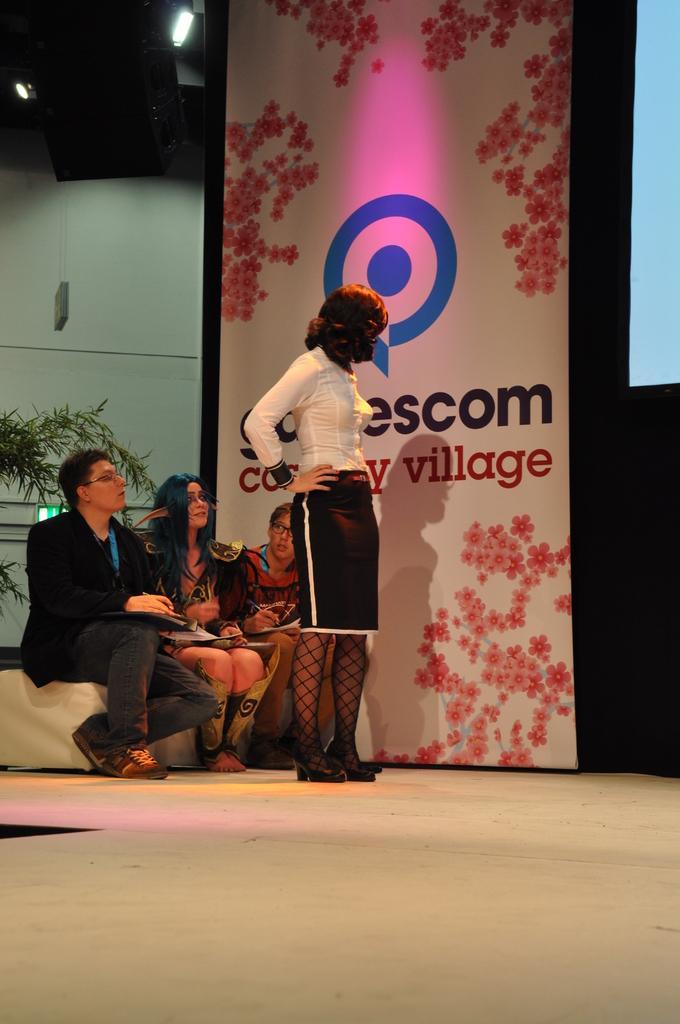How would you summarize this image in a sentence or two? In the center of the image there is a woman standing on the dais. On the left side of the image there are persons sitting. In the background there is a wall, poster and screen. 